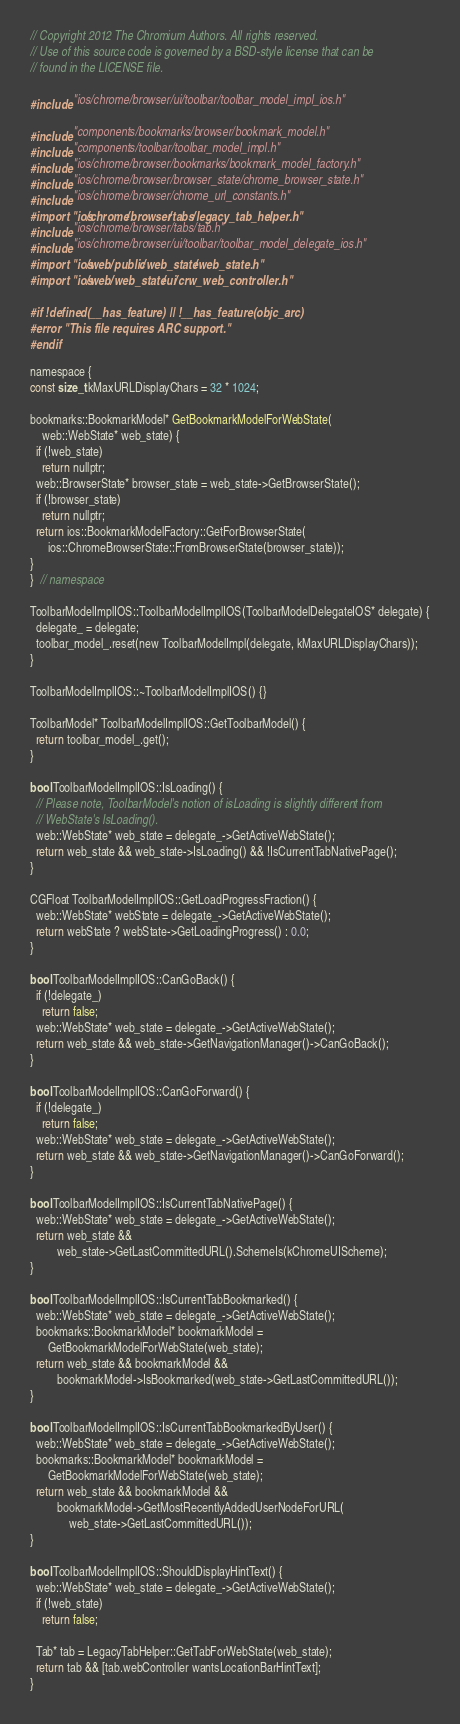<code> <loc_0><loc_0><loc_500><loc_500><_ObjectiveC_>// Copyright 2012 The Chromium Authors. All rights reserved.
// Use of this source code is governed by a BSD-style license that can be
// found in the LICENSE file.

#include "ios/chrome/browser/ui/toolbar/toolbar_model_impl_ios.h"

#include "components/bookmarks/browser/bookmark_model.h"
#include "components/toolbar/toolbar_model_impl.h"
#include "ios/chrome/browser/bookmarks/bookmark_model_factory.h"
#include "ios/chrome/browser/browser_state/chrome_browser_state.h"
#include "ios/chrome/browser/chrome_url_constants.h"
#import "ios/chrome/browser/tabs/legacy_tab_helper.h"
#include "ios/chrome/browser/tabs/tab.h"
#include "ios/chrome/browser/ui/toolbar/toolbar_model_delegate_ios.h"
#import "ios/web/public/web_state/web_state.h"
#import "ios/web/web_state/ui/crw_web_controller.h"

#if !defined(__has_feature) || !__has_feature(objc_arc)
#error "This file requires ARC support."
#endif

namespace {
const size_t kMaxURLDisplayChars = 32 * 1024;

bookmarks::BookmarkModel* GetBookmarkModelForWebState(
    web::WebState* web_state) {
  if (!web_state)
    return nullptr;
  web::BrowserState* browser_state = web_state->GetBrowserState();
  if (!browser_state)
    return nullptr;
  return ios::BookmarkModelFactory::GetForBrowserState(
      ios::ChromeBrowserState::FromBrowserState(browser_state));
}
}  // namespace

ToolbarModelImplIOS::ToolbarModelImplIOS(ToolbarModelDelegateIOS* delegate) {
  delegate_ = delegate;
  toolbar_model_.reset(new ToolbarModelImpl(delegate, kMaxURLDisplayChars));
}

ToolbarModelImplIOS::~ToolbarModelImplIOS() {}

ToolbarModel* ToolbarModelImplIOS::GetToolbarModel() {
  return toolbar_model_.get();
}

bool ToolbarModelImplIOS::IsLoading() {
  // Please note, ToolbarModel's notion of isLoading is slightly different from
  // WebState's IsLoading().
  web::WebState* web_state = delegate_->GetActiveWebState();
  return web_state && web_state->IsLoading() && !IsCurrentTabNativePage();
}

CGFloat ToolbarModelImplIOS::GetLoadProgressFraction() {
  web::WebState* webState = delegate_->GetActiveWebState();
  return webState ? webState->GetLoadingProgress() : 0.0;
}

bool ToolbarModelImplIOS::CanGoBack() {
  if (!delegate_)
    return false;
  web::WebState* web_state = delegate_->GetActiveWebState();
  return web_state && web_state->GetNavigationManager()->CanGoBack();
}

bool ToolbarModelImplIOS::CanGoForward() {
  if (!delegate_)
    return false;
  web::WebState* web_state = delegate_->GetActiveWebState();
  return web_state && web_state->GetNavigationManager()->CanGoForward();
}

bool ToolbarModelImplIOS::IsCurrentTabNativePage() {
  web::WebState* web_state = delegate_->GetActiveWebState();
  return web_state &&
         web_state->GetLastCommittedURL().SchemeIs(kChromeUIScheme);
}

bool ToolbarModelImplIOS::IsCurrentTabBookmarked() {
  web::WebState* web_state = delegate_->GetActiveWebState();
  bookmarks::BookmarkModel* bookmarkModel =
      GetBookmarkModelForWebState(web_state);
  return web_state && bookmarkModel &&
         bookmarkModel->IsBookmarked(web_state->GetLastCommittedURL());
}

bool ToolbarModelImplIOS::IsCurrentTabBookmarkedByUser() {
  web::WebState* web_state = delegate_->GetActiveWebState();
  bookmarks::BookmarkModel* bookmarkModel =
      GetBookmarkModelForWebState(web_state);
  return web_state && bookmarkModel &&
         bookmarkModel->GetMostRecentlyAddedUserNodeForURL(
             web_state->GetLastCommittedURL());
}

bool ToolbarModelImplIOS::ShouldDisplayHintText() {
  web::WebState* web_state = delegate_->GetActiveWebState();
  if (!web_state)
    return false;

  Tab* tab = LegacyTabHelper::GetTabForWebState(web_state);
  return tab && [tab.webController wantsLocationBarHintText];
}
</code> 